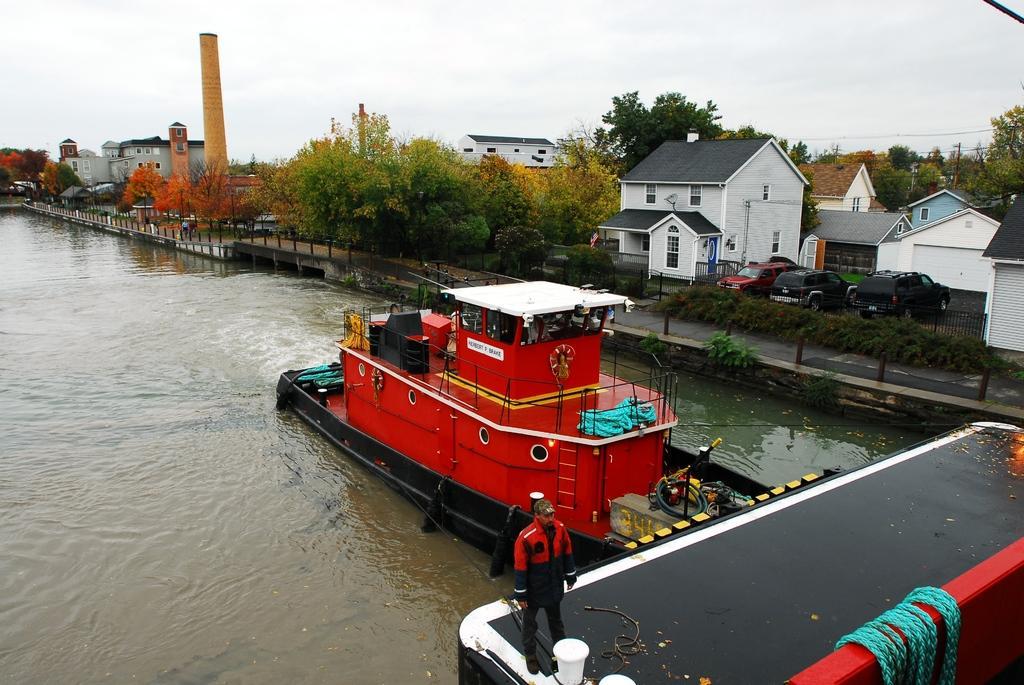Could you give a brief overview of what you see in this image? This looks like a ship moving on the water. I think this is the river. Here is a person standing. This looks like a rope. These are the houses with windows and doors. I can see three cars, which are parked. This looks like a tower, which is yellow in color. These are the trees with colorful leaves. 